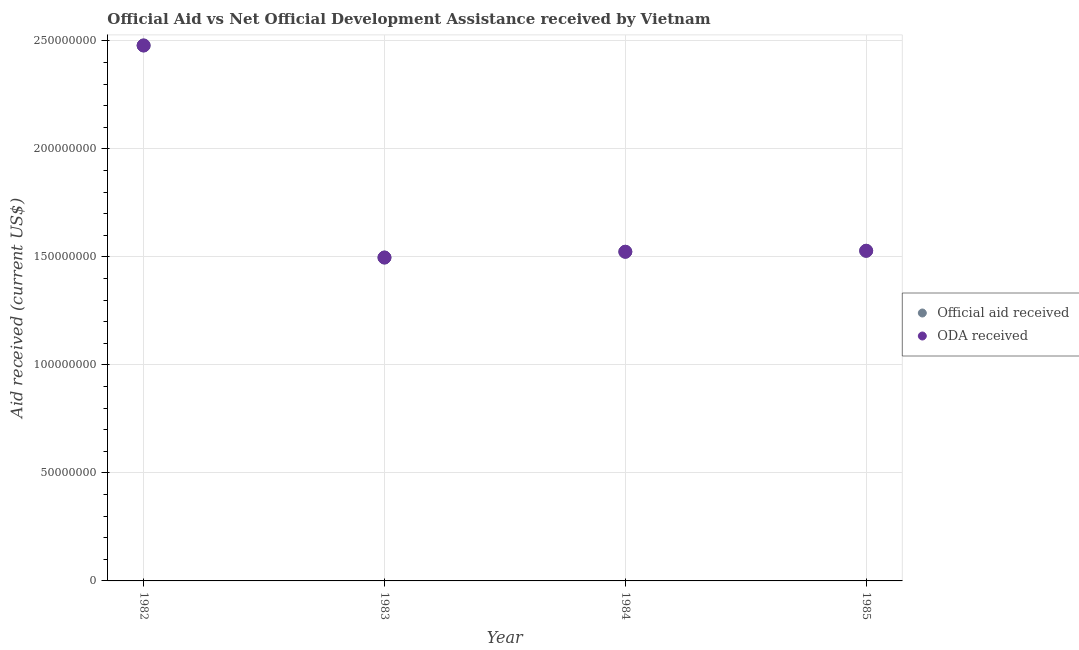Is the number of dotlines equal to the number of legend labels?
Offer a terse response. Yes. What is the oda received in 1983?
Offer a very short reply. 1.50e+08. Across all years, what is the maximum official aid received?
Provide a short and direct response. 2.48e+08. Across all years, what is the minimum official aid received?
Ensure brevity in your answer.  1.50e+08. In which year was the official aid received maximum?
Your response must be concise. 1982. In which year was the oda received minimum?
Offer a very short reply. 1983. What is the total official aid received in the graph?
Ensure brevity in your answer.  7.03e+08. What is the difference between the oda received in 1982 and that in 1984?
Provide a succinct answer. 9.55e+07. What is the difference between the official aid received in 1983 and the oda received in 1984?
Keep it short and to the point. -2.67e+06. What is the average oda received per year?
Ensure brevity in your answer.  1.76e+08. In the year 1984, what is the difference between the official aid received and oda received?
Make the answer very short. 0. In how many years, is the official aid received greater than 80000000 US$?
Give a very brief answer. 4. What is the ratio of the official aid received in 1983 to that in 1984?
Provide a short and direct response. 0.98. Is the oda received in 1982 less than that in 1985?
Make the answer very short. No. What is the difference between the highest and the second highest official aid received?
Provide a short and direct response. 9.50e+07. What is the difference between the highest and the lowest official aid received?
Provide a short and direct response. 9.82e+07. In how many years, is the official aid received greater than the average official aid received taken over all years?
Ensure brevity in your answer.  1. Is the sum of the oda received in 1982 and 1983 greater than the maximum official aid received across all years?
Your answer should be very brief. Yes. Does the official aid received monotonically increase over the years?
Give a very brief answer. No. Is the official aid received strictly less than the oda received over the years?
Your answer should be compact. No. Are the values on the major ticks of Y-axis written in scientific E-notation?
Ensure brevity in your answer.  No. Does the graph contain any zero values?
Offer a very short reply. No. How many legend labels are there?
Your response must be concise. 2. What is the title of the graph?
Ensure brevity in your answer.  Official Aid vs Net Official Development Assistance received by Vietnam . What is the label or title of the Y-axis?
Your response must be concise. Aid received (current US$). What is the Aid received (current US$) in Official aid received in 1982?
Your response must be concise. 2.48e+08. What is the Aid received (current US$) of ODA received in 1982?
Make the answer very short. 2.48e+08. What is the Aid received (current US$) in Official aid received in 1983?
Provide a succinct answer. 1.50e+08. What is the Aid received (current US$) of ODA received in 1983?
Give a very brief answer. 1.50e+08. What is the Aid received (current US$) of Official aid received in 1984?
Make the answer very short. 1.52e+08. What is the Aid received (current US$) of ODA received in 1984?
Offer a terse response. 1.52e+08. What is the Aid received (current US$) in Official aid received in 1985?
Ensure brevity in your answer.  1.53e+08. What is the Aid received (current US$) of ODA received in 1985?
Offer a terse response. 1.53e+08. Across all years, what is the maximum Aid received (current US$) of Official aid received?
Provide a short and direct response. 2.48e+08. Across all years, what is the maximum Aid received (current US$) in ODA received?
Provide a short and direct response. 2.48e+08. Across all years, what is the minimum Aid received (current US$) of Official aid received?
Keep it short and to the point. 1.50e+08. Across all years, what is the minimum Aid received (current US$) in ODA received?
Keep it short and to the point. 1.50e+08. What is the total Aid received (current US$) in Official aid received in the graph?
Make the answer very short. 7.03e+08. What is the total Aid received (current US$) in ODA received in the graph?
Your answer should be very brief. 7.03e+08. What is the difference between the Aid received (current US$) in Official aid received in 1982 and that in 1983?
Offer a terse response. 9.82e+07. What is the difference between the Aid received (current US$) in ODA received in 1982 and that in 1983?
Your response must be concise. 9.82e+07. What is the difference between the Aid received (current US$) in Official aid received in 1982 and that in 1984?
Keep it short and to the point. 9.55e+07. What is the difference between the Aid received (current US$) in ODA received in 1982 and that in 1984?
Offer a very short reply. 9.55e+07. What is the difference between the Aid received (current US$) of Official aid received in 1982 and that in 1985?
Your answer should be very brief. 9.50e+07. What is the difference between the Aid received (current US$) in ODA received in 1982 and that in 1985?
Your answer should be very brief. 9.50e+07. What is the difference between the Aid received (current US$) in Official aid received in 1983 and that in 1984?
Offer a terse response. -2.67e+06. What is the difference between the Aid received (current US$) in ODA received in 1983 and that in 1984?
Keep it short and to the point. -2.67e+06. What is the difference between the Aid received (current US$) of Official aid received in 1983 and that in 1985?
Provide a short and direct response. -3.12e+06. What is the difference between the Aid received (current US$) in ODA received in 1983 and that in 1985?
Your answer should be very brief. -3.12e+06. What is the difference between the Aid received (current US$) of Official aid received in 1984 and that in 1985?
Offer a terse response. -4.50e+05. What is the difference between the Aid received (current US$) in ODA received in 1984 and that in 1985?
Offer a very short reply. -4.50e+05. What is the difference between the Aid received (current US$) of Official aid received in 1982 and the Aid received (current US$) of ODA received in 1983?
Make the answer very short. 9.82e+07. What is the difference between the Aid received (current US$) of Official aid received in 1982 and the Aid received (current US$) of ODA received in 1984?
Keep it short and to the point. 9.55e+07. What is the difference between the Aid received (current US$) in Official aid received in 1982 and the Aid received (current US$) in ODA received in 1985?
Your answer should be very brief. 9.50e+07. What is the difference between the Aid received (current US$) in Official aid received in 1983 and the Aid received (current US$) in ODA received in 1984?
Ensure brevity in your answer.  -2.67e+06. What is the difference between the Aid received (current US$) of Official aid received in 1983 and the Aid received (current US$) of ODA received in 1985?
Your response must be concise. -3.12e+06. What is the difference between the Aid received (current US$) in Official aid received in 1984 and the Aid received (current US$) in ODA received in 1985?
Offer a terse response. -4.50e+05. What is the average Aid received (current US$) of Official aid received per year?
Ensure brevity in your answer.  1.76e+08. What is the average Aid received (current US$) of ODA received per year?
Your answer should be compact. 1.76e+08. In the year 1983, what is the difference between the Aid received (current US$) in Official aid received and Aid received (current US$) in ODA received?
Offer a terse response. 0. In the year 1985, what is the difference between the Aid received (current US$) in Official aid received and Aid received (current US$) in ODA received?
Make the answer very short. 0. What is the ratio of the Aid received (current US$) in Official aid received in 1982 to that in 1983?
Offer a terse response. 1.66. What is the ratio of the Aid received (current US$) of ODA received in 1982 to that in 1983?
Offer a very short reply. 1.66. What is the ratio of the Aid received (current US$) in Official aid received in 1982 to that in 1984?
Your response must be concise. 1.63. What is the ratio of the Aid received (current US$) of ODA received in 1982 to that in 1984?
Offer a very short reply. 1.63. What is the ratio of the Aid received (current US$) in Official aid received in 1982 to that in 1985?
Provide a short and direct response. 1.62. What is the ratio of the Aid received (current US$) in ODA received in 1982 to that in 1985?
Give a very brief answer. 1.62. What is the ratio of the Aid received (current US$) of Official aid received in 1983 to that in 1984?
Give a very brief answer. 0.98. What is the ratio of the Aid received (current US$) of ODA received in 1983 to that in 1984?
Keep it short and to the point. 0.98. What is the ratio of the Aid received (current US$) of Official aid received in 1983 to that in 1985?
Your response must be concise. 0.98. What is the ratio of the Aid received (current US$) in ODA received in 1983 to that in 1985?
Give a very brief answer. 0.98. What is the ratio of the Aid received (current US$) in Official aid received in 1984 to that in 1985?
Offer a very short reply. 1. What is the difference between the highest and the second highest Aid received (current US$) of Official aid received?
Your response must be concise. 9.50e+07. What is the difference between the highest and the second highest Aid received (current US$) in ODA received?
Give a very brief answer. 9.50e+07. What is the difference between the highest and the lowest Aid received (current US$) in Official aid received?
Provide a short and direct response. 9.82e+07. What is the difference between the highest and the lowest Aid received (current US$) of ODA received?
Your answer should be very brief. 9.82e+07. 